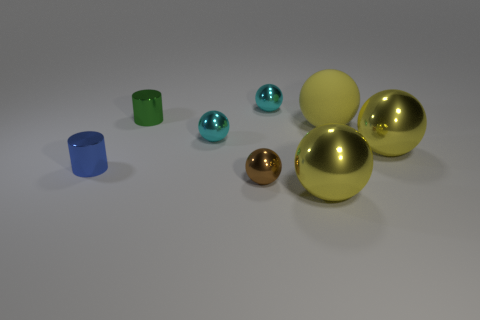How many small things are either gray rubber blocks or shiny balls?
Offer a terse response. 3. What number of other objects are there of the same color as the rubber thing?
Your response must be concise. 2. There is a large yellow sphere that is in front of the large ball that is right of the large yellow rubber ball; how many small shiny things are on the right side of it?
Keep it short and to the point. 0. Does the yellow metallic object that is to the right of the yellow rubber thing have the same size as the brown object?
Offer a terse response. No. Are there fewer blue things that are to the right of the small green metallic cylinder than small cyan shiny things that are behind the blue thing?
Keep it short and to the point. Yes. Are there fewer metallic balls that are on the left side of the small brown thing than big cyan metal objects?
Give a very brief answer. No. Do the brown object and the small blue cylinder have the same material?
Your response must be concise. Yes. What number of cyan objects are made of the same material as the tiny green cylinder?
Provide a succinct answer. 2. There is another cylinder that is made of the same material as the blue cylinder; what color is it?
Ensure brevity in your answer.  Green. The large rubber thing is what shape?
Provide a short and direct response. Sphere. 